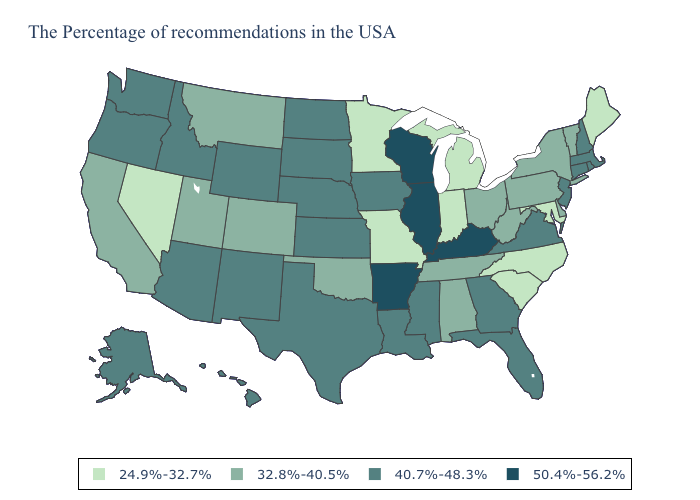What is the value of West Virginia?
Quick response, please. 32.8%-40.5%. Does Arkansas have the highest value in the USA?
Be succinct. Yes. Among the states that border Florida , does Alabama have the lowest value?
Answer briefly. Yes. Name the states that have a value in the range 50.4%-56.2%?
Give a very brief answer. Kentucky, Wisconsin, Illinois, Arkansas. Name the states that have a value in the range 24.9%-32.7%?
Concise answer only. Maine, Maryland, North Carolina, South Carolina, Michigan, Indiana, Missouri, Minnesota, Nevada. Among the states that border New Mexico , does Oklahoma have the highest value?
Be succinct. No. What is the highest value in the USA?
Be succinct. 50.4%-56.2%. Name the states that have a value in the range 24.9%-32.7%?
Answer briefly. Maine, Maryland, North Carolina, South Carolina, Michigan, Indiana, Missouri, Minnesota, Nevada. Among the states that border Utah , does New Mexico have the lowest value?
Concise answer only. No. Which states have the lowest value in the South?
Concise answer only. Maryland, North Carolina, South Carolina. Name the states that have a value in the range 32.8%-40.5%?
Write a very short answer. Vermont, New York, Delaware, Pennsylvania, West Virginia, Ohio, Alabama, Tennessee, Oklahoma, Colorado, Utah, Montana, California. Does Ohio have the lowest value in the MidWest?
Quick response, please. No. Name the states that have a value in the range 40.7%-48.3%?
Give a very brief answer. Massachusetts, Rhode Island, New Hampshire, Connecticut, New Jersey, Virginia, Florida, Georgia, Mississippi, Louisiana, Iowa, Kansas, Nebraska, Texas, South Dakota, North Dakota, Wyoming, New Mexico, Arizona, Idaho, Washington, Oregon, Alaska, Hawaii. What is the value of Maine?
Concise answer only. 24.9%-32.7%. Which states have the lowest value in the USA?
Write a very short answer. Maine, Maryland, North Carolina, South Carolina, Michigan, Indiana, Missouri, Minnesota, Nevada. 